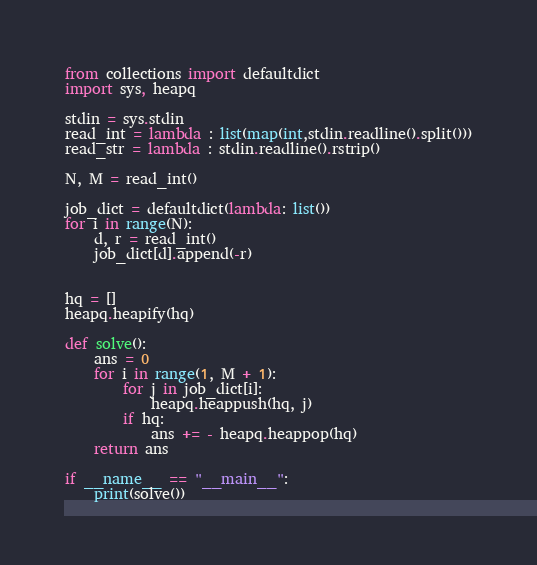Convert code to text. <code><loc_0><loc_0><loc_500><loc_500><_Python_>from collections import defaultdict
import sys, heapq

stdin = sys.stdin
read_int = lambda : list(map(int,stdin.readline().split()))
read_str = lambda : stdin.readline().rstrip()

N, M = read_int()

job_dict = defaultdict(lambda: list())
for i in range(N):
    d, r = read_int()
    job_dict[d].append(-r)


hq = []
heapq.heapify(hq)

def solve():
    ans = 0
    for i in range(1, M + 1):
        for j in job_dict[i]:
            heapq.heappush(hq, j)
        if hq:
            ans += - heapq.heappop(hq)
    return ans

if __name__ == "__main__":
    print(solve())</code> 